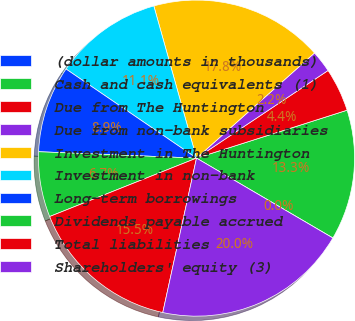<chart> <loc_0><loc_0><loc_500><loc_500><pie_chart><fcel>(dollar amounts in thousands)<fcel>Cash and cash equivalents (1)<fcel>Due from The Huntington<fcel>Due from non-bank subsidiaries<fcel>Investment in The Huntington<fcel>Investment in non-bank<fcel>Long-term borrowings<fcel>Dividends payable accrued<fcel>Total liabilities<fcel>Shareholders' equity (3)<nl><fcel>0.01%<fcel>13.33%<fcel>4.45%<fcel>2.23%<fcel>17.77%<fcel>11.11%<fcel>8.89%<fcel>6.67%<fcel>15.55%<fcel>19.99%<nl></chart> 